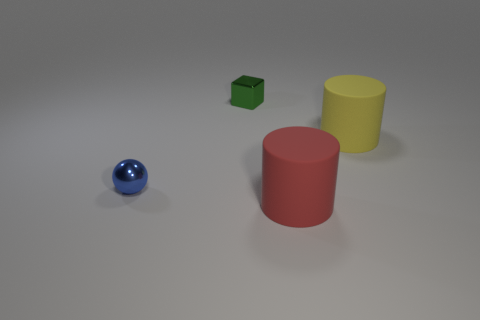Add 3 balls. How many objects exist? 7 Subtract 1 cubes. How many cubes are left? 0 Subtract all cubes. How many objects are left? 3 Subtract all shiny objects. Subtract all small red metallic blocks. How many objects are left? 2 Add 1 small blocks. How many small blocks are left? 2 Add 2 large yellow things. How many large yellow things exist? 3 Subtract 0 cyan cubes. How many objects are left? 4 Subtract all green balls. Subtract all gray cubes. How many balls are left? 1 Subtract all yellow spheres. How many yellow cylinders are left? 1 